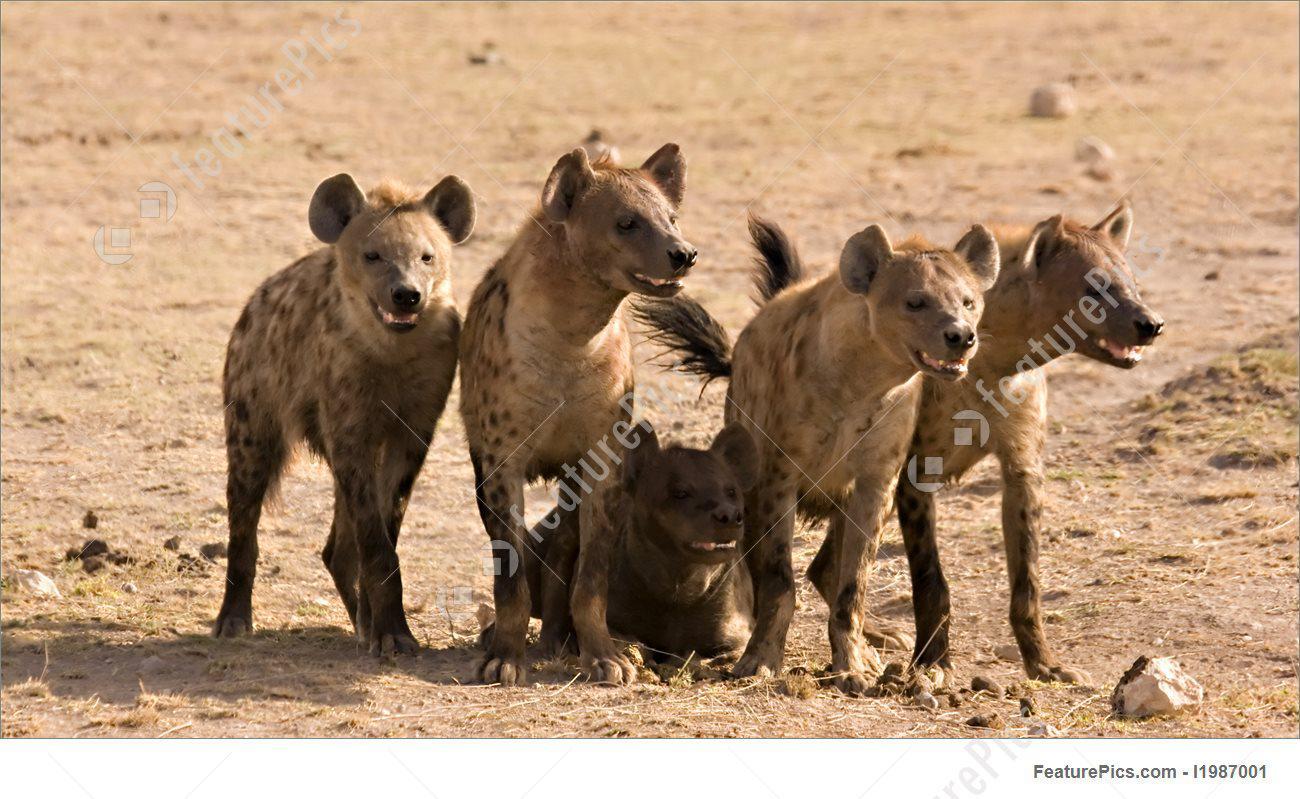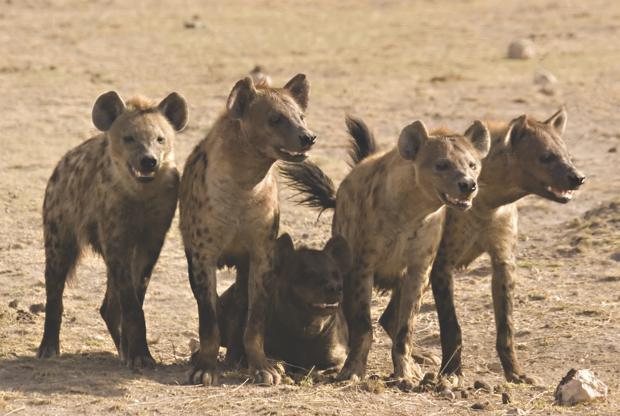The first image is the image on the left, the second image is the image on the right. For the images displayed, is the sentence "One hyena sits while two stand on either side of it." factually correct? Answer yes or no. Yes. 